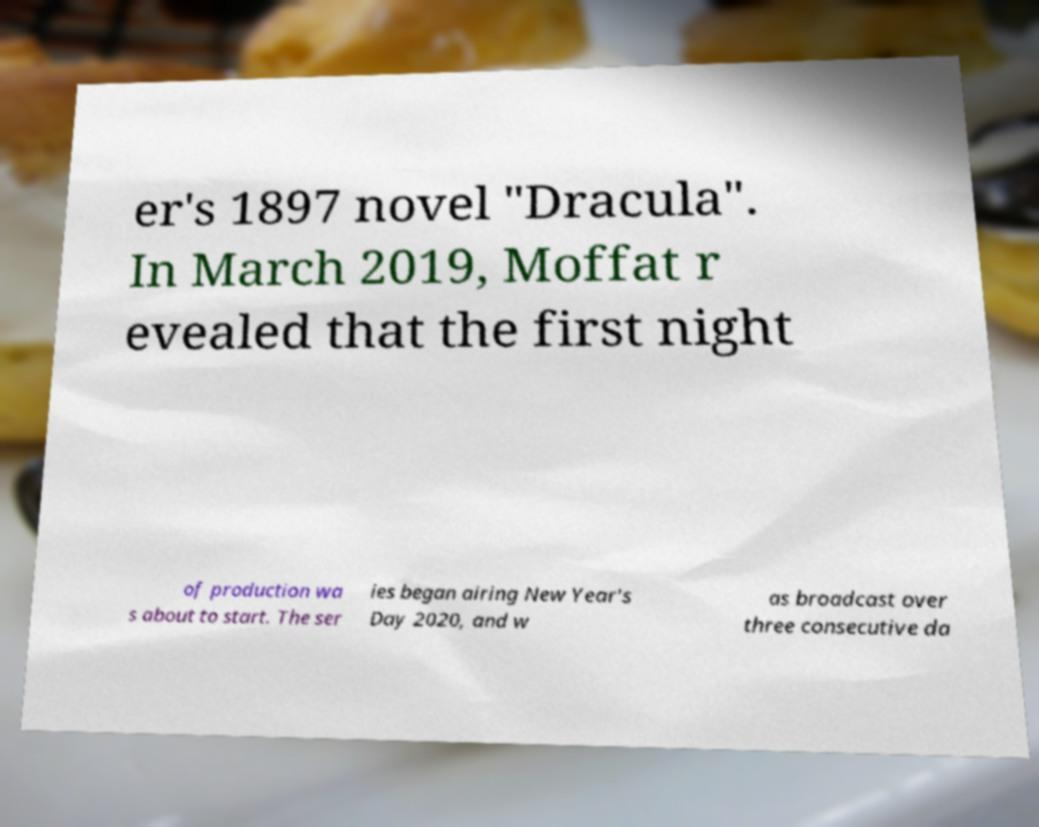Can you read and provide the text displayed in the image?This photo seems to have some interesting text. Can you extract and type it out for me? er's 1897 novel "Dracula". In March 2019, Moffat r evealed that the first night of production wa s about to start. The ser ies began airing New Year's Day 2020, and w as broadcast over three consecutive da 